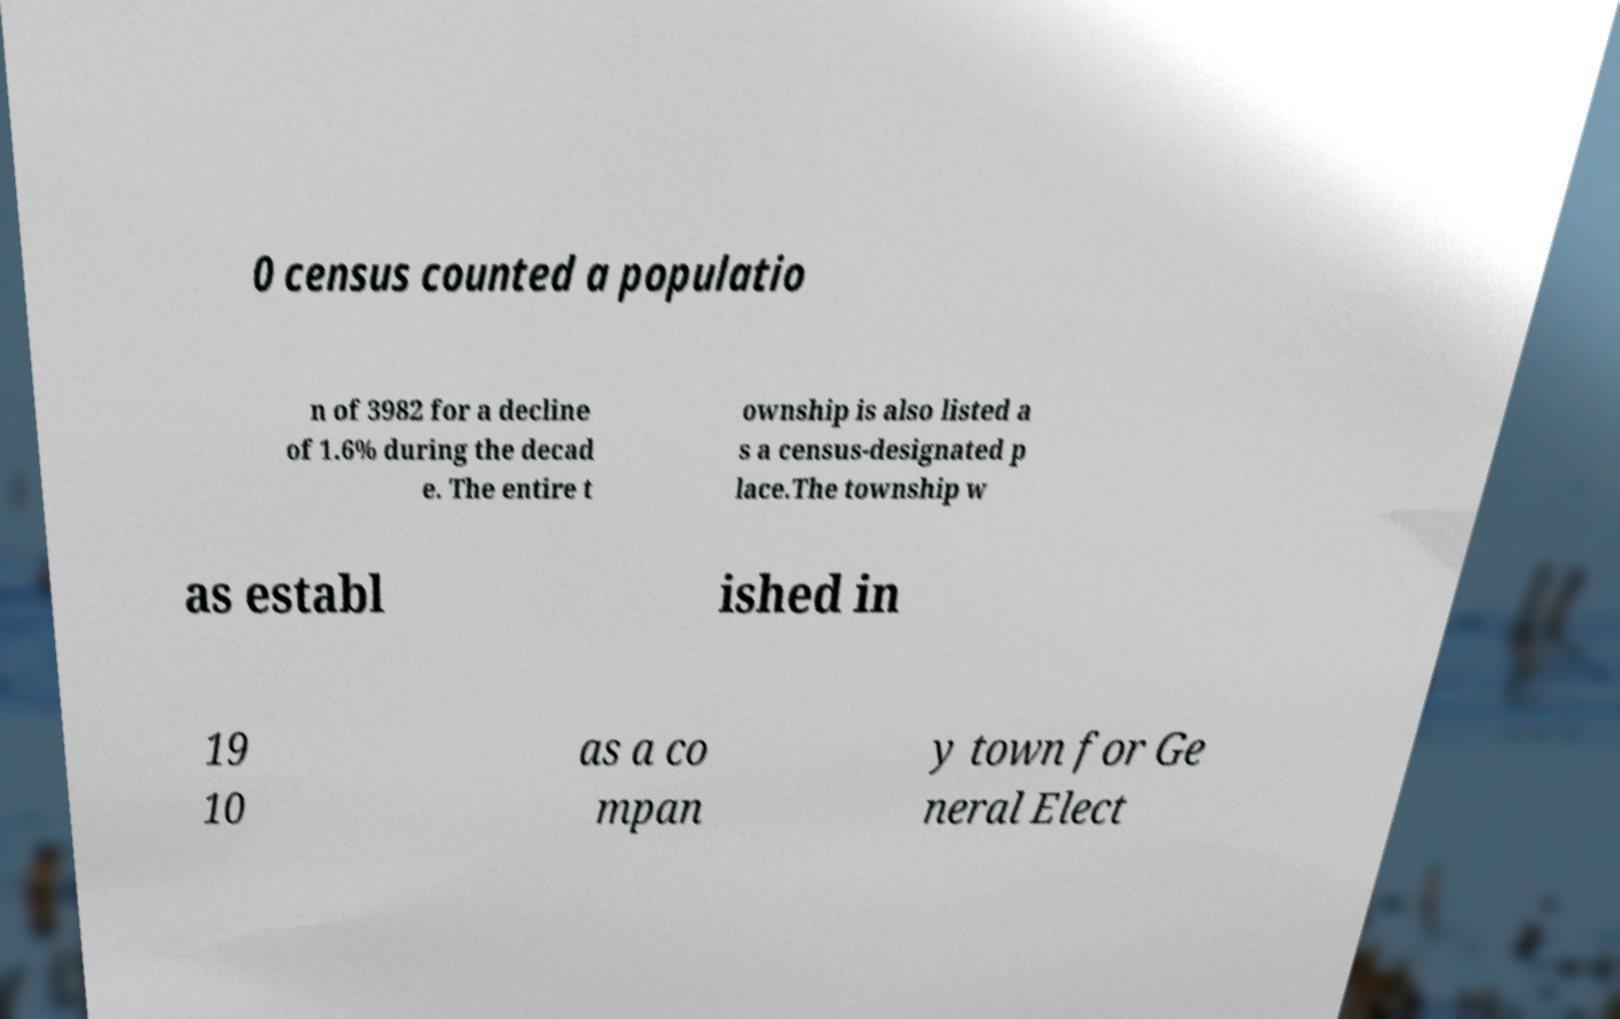Please identify and transcribe the text found in this image. 0 census counted a populatio n of 3982 for a decline of 1.6% during the decad e. The entire t ownship is also listed a s a census-designated p lace.The township w as establ ished in 19 10 as a co mpan y town for Ge neral Elect 